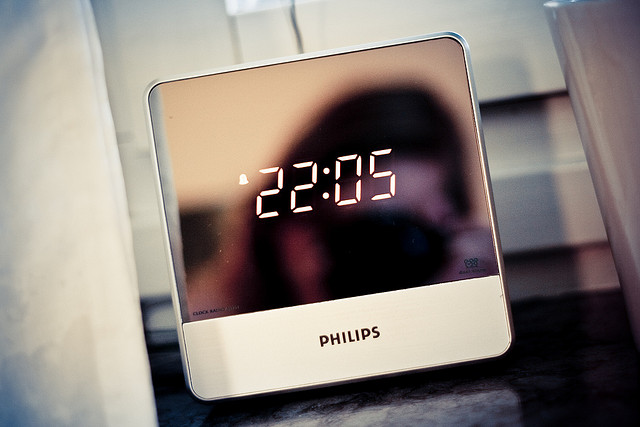Read all the text in this image. 22 :05 PHILIPS 